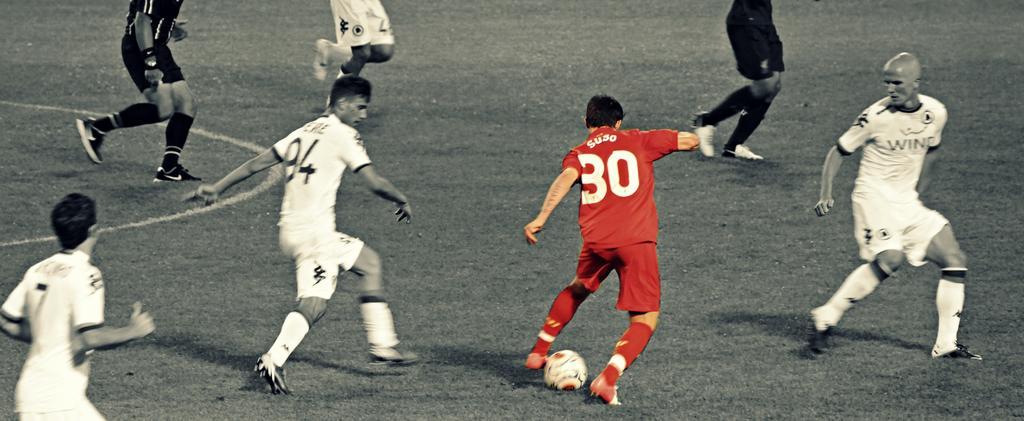Please provide a concise description of this image. In this picture we can see some persons playing football in the ground. and this is the grass. 